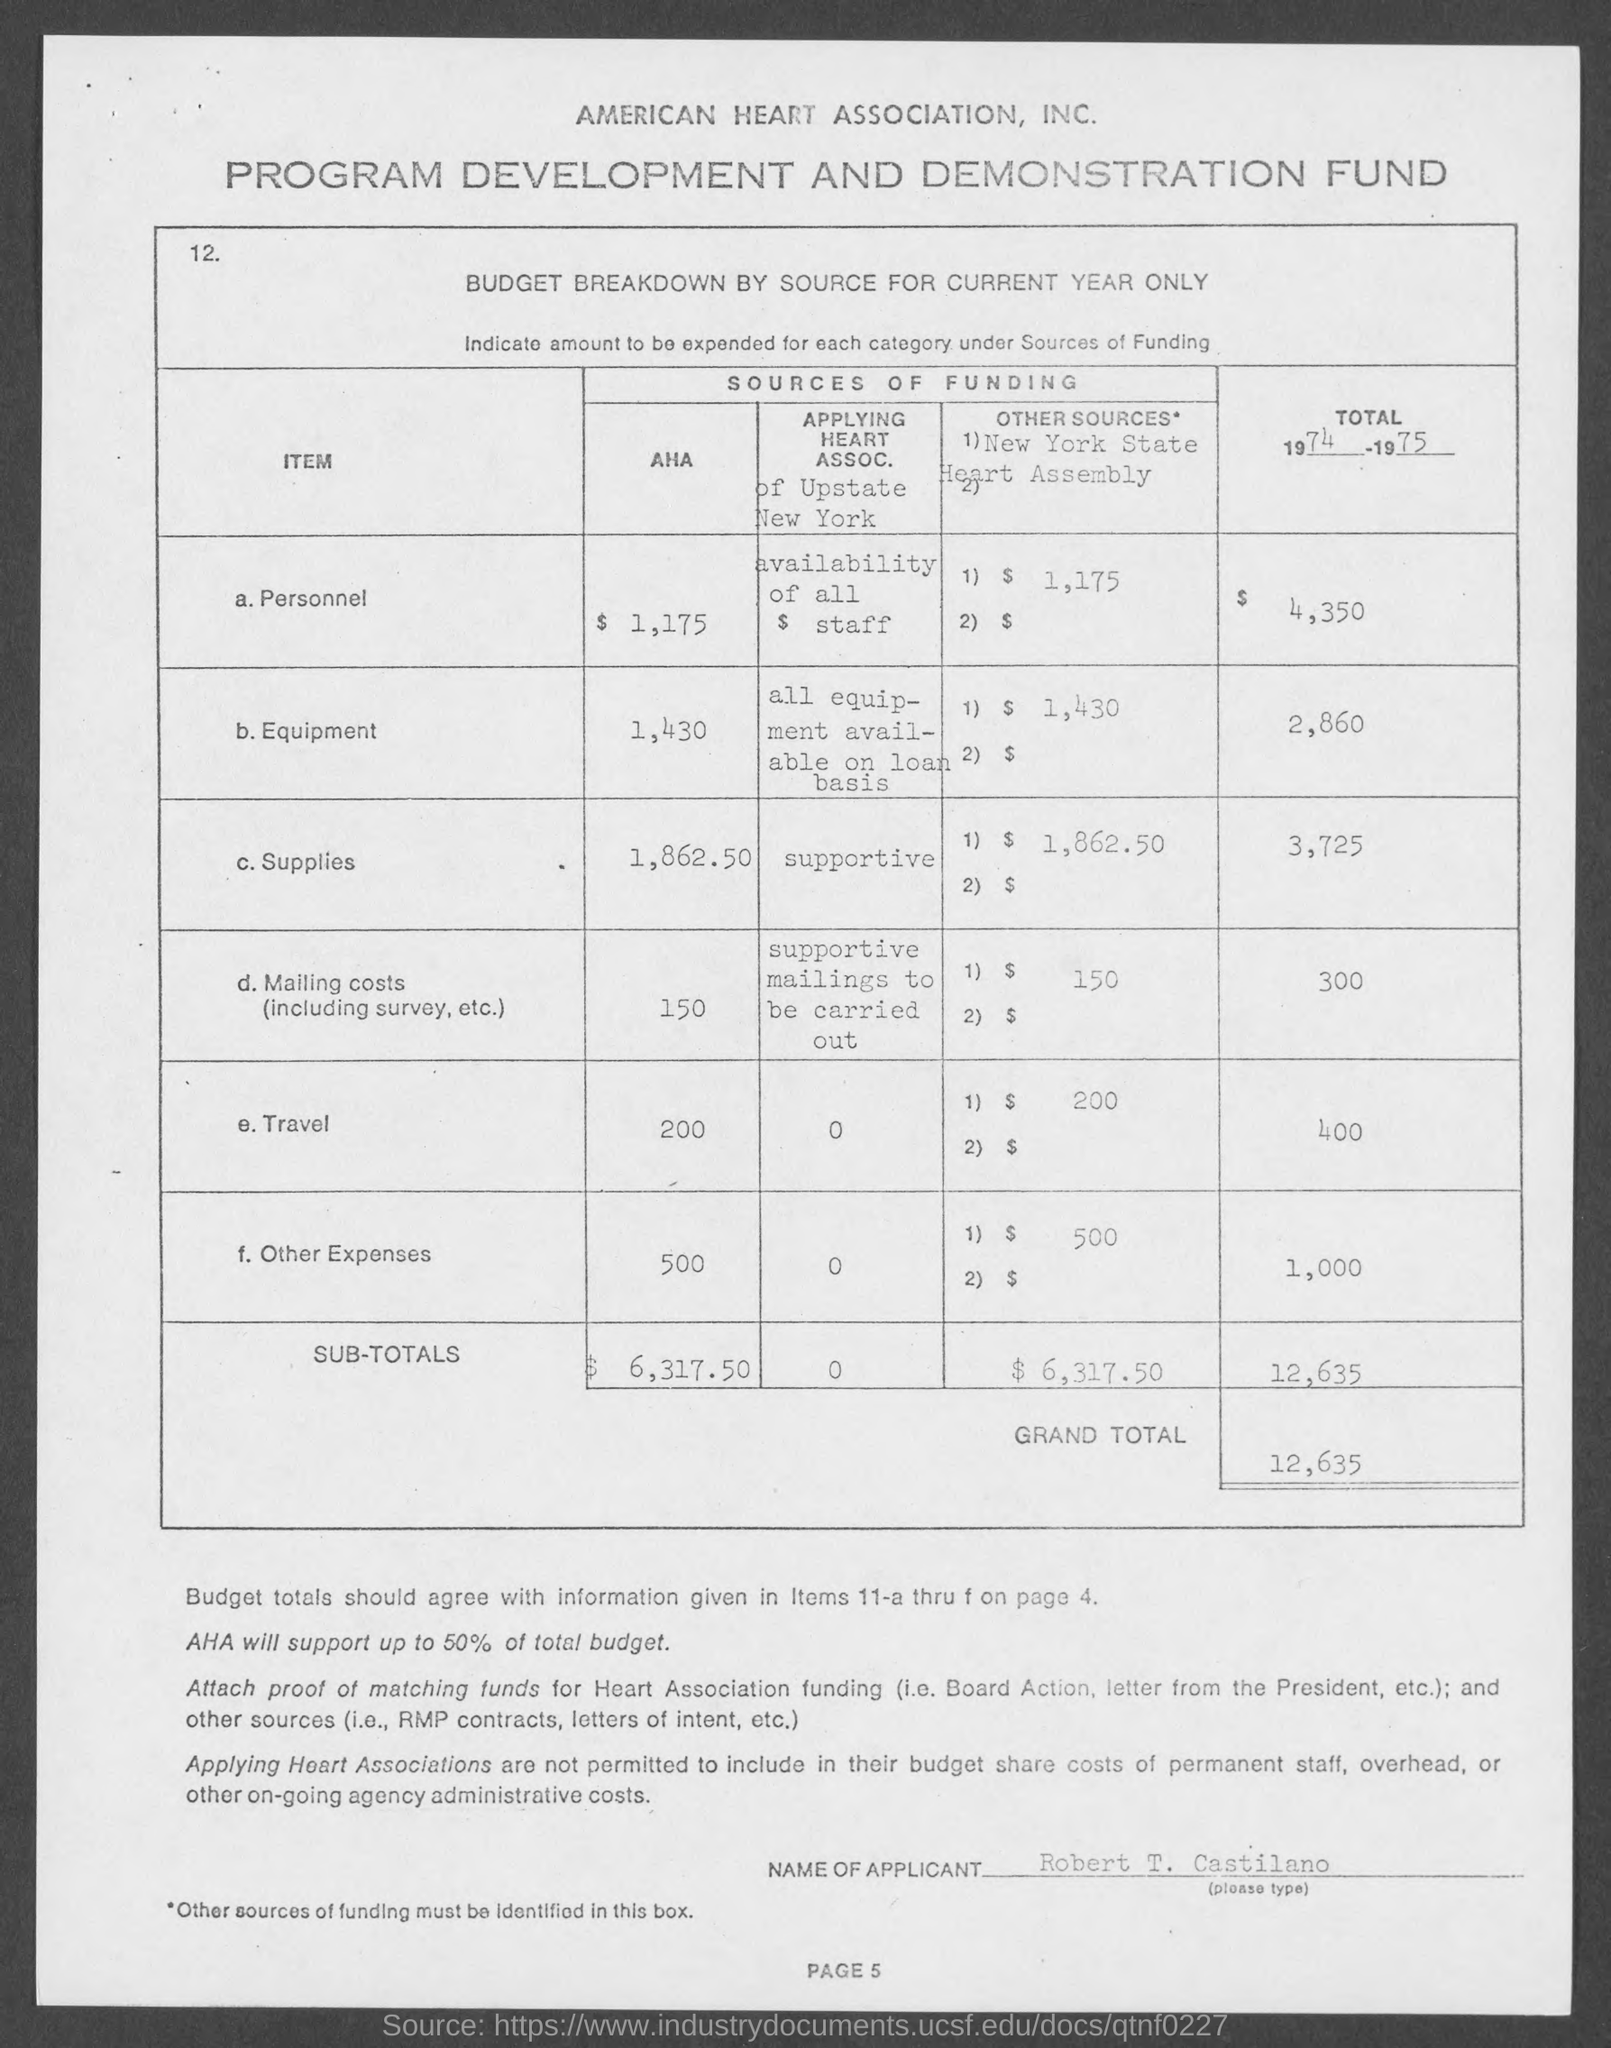What is the total for 1974 - 1975 for Personnel?
Your answer should be very brief. $ 4,350. What is the total for 1974 - 1975 for Equipment?
Offer a terse response. 2,860. What is the total for 1974 - 1975 for Supplies?
Keep it short and to the point. 3,725. What is the total for 1974 - 1975 for Mailing Costs?
Ensure brevity in your answer.  300. What is the total for 1974 - 1975 for Travel?
Your response must be concise. 400. What is the total for 1974 - 1975 for Other Expenses?
Keep it short and to the point. 1,000. What are the subtotals for AHA?
Your response must be concise. $6,317.50. What are the subtotals for Other sources?
Your answer should be compact. $6,317.50. What is the total for 1974 - 1975 Subtotal?
Keep it short and to the point. 12,635. What is the Grand Total?
Keep it short and to the point. 12,635. 